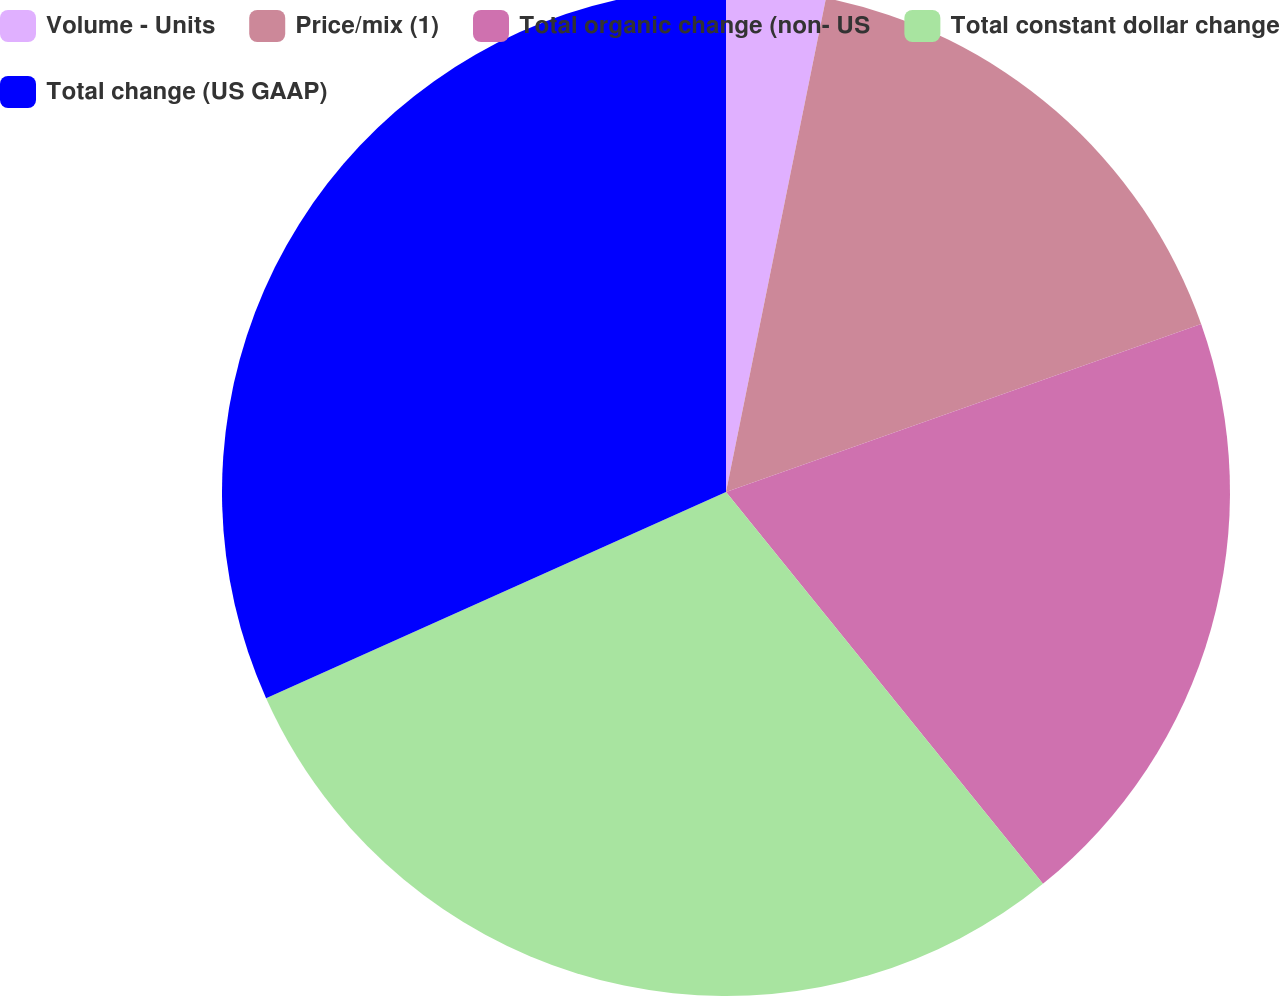Convert chart to OTSL. <chart><loc_0><loc_0><loc_500><loc_500><pie_chart><fcel>Volume - Units<fcel>Price/mix (1)<fcel>Total organic change (non- US<fcel>Total constant dollar change<fcel>Total change (US GAAP)<nl><fcel>3.18%<fcel>16.41%<fcel>19.59%<fcel>29.12%<fcel>31.71%<nl></chart> 